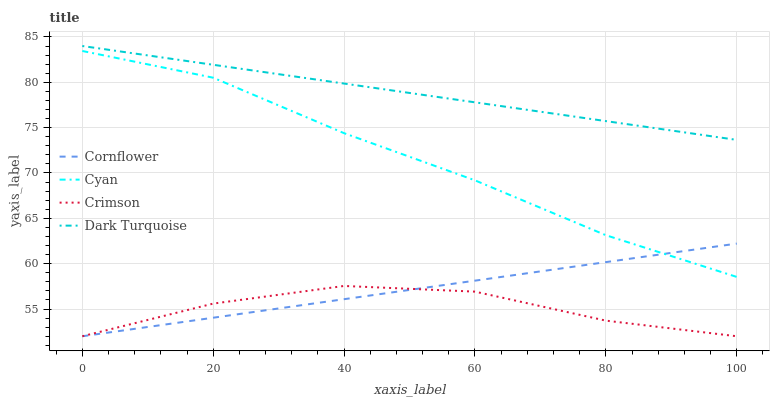Does Crimson have the minimum area under the curve?
Answer yes or no. Yes. Does Dark Turquoise have the maximum area under the curve?
Answer yes or no. Yes. Does Cornflower have the minimum area under the curve?
Answer yes or no. No. Does Cornflower have the maximum area under the curve?
Answer yes or no. No. Is Dark Turquoise the smoothest?
Answer yes or no. Yes. Is Crimson the roughest?
Answer yes or no. Yes. Is Cornflower the smoothest?
Answer yes or no. No. Is Cornflower the roughest?
Answer yes or no. No. Does Crimson have the lowest value?
Answer yes or no. Yes. Does Dark Turquoise have the lowest value?
Answer yes or no. No. Does Dark Turquoise have the highest value?
Answer yes or no. Yes. Does Cornflower have the highest value?
Answer yes or no. No. Is Cornflower less than Dark Turquoise?
Answer yes or no. Yes. Is Dark Turquoise greater than Cyan?
Answer yes or no. Yes. Does Cornflower intersect Cyan?
Answer yes or no. Yes. Is Cornflower less than Cyan?
Answer yes or no. No. Is Cornflower greater than Cyan?
Answer yes or no. No. Does Cornflower intersect Dark Turquoise?
Answer yes or no. No. 